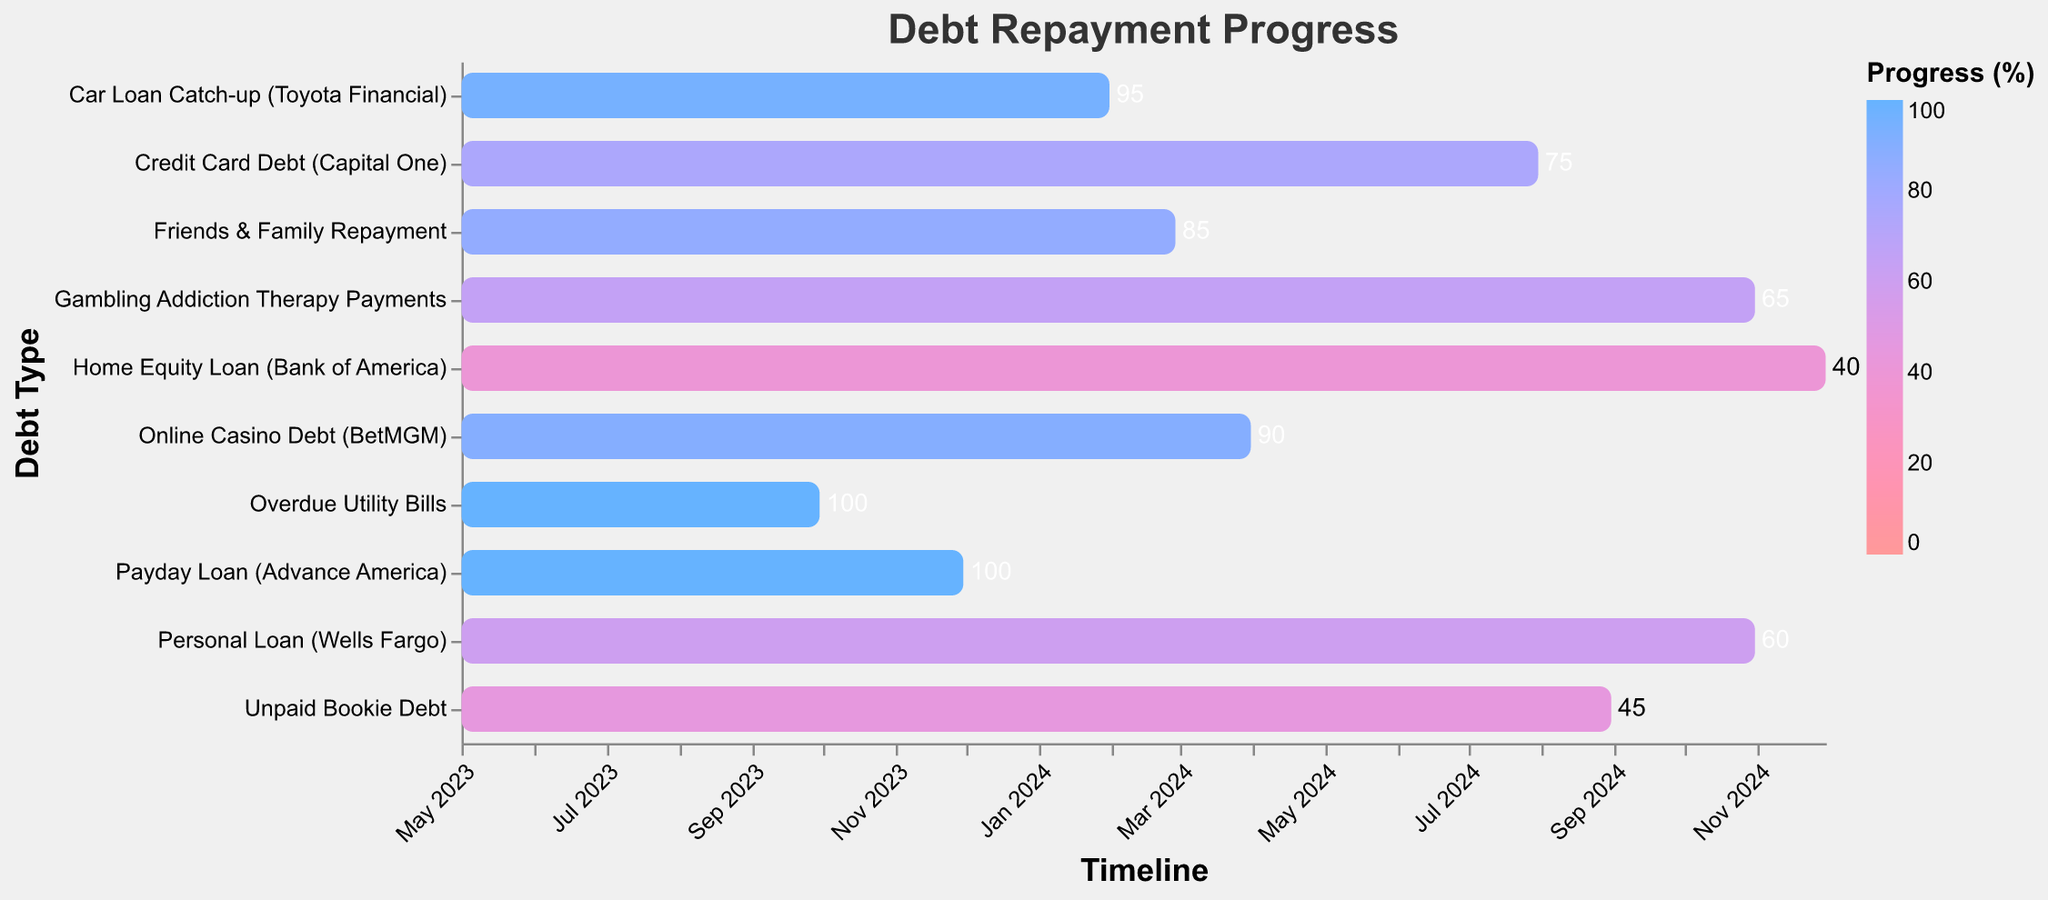Which debt has the highest repayment progress? The debt with the highest repayment progress is the one with the highest percentage on the color scale. By looking at the chart, the "Payday Loan (Advance America)" and "Overdue Utility Bills" both have a progress of 100%.
Answer: Payday Loan (Advance America) and Overdue Utility Bills When is the repayment of the "Online Casino Debt (BetMGM)" expected to be completed? The end date for the "Online Casino Debt (BetMGM)" on the chart indicates when the repayment plan is expected to be completed. The end date is March 31, 2024.
Answer: March 31, 2024 What is the total duration for repaying the "Home Equity Loan (Bank of America)"? To calculate the total duration, subtract the start date from the end date for the "Home Equity Loan (Bank of America)". The start date is May 1, 2023, and the end date is November 30, 2024. The duration is approximately 19 months.
Answer: 19 months Which debts are fully repaid as of now? Fully repaid debts have a progress of 100%. By looking at the chart, "Payday Loan (Advance America)" and "Overdue Utility Bills" have 100% completion.
Answer: Payday Loan (Advance America) and Overdue Utility Bills Which debt has the lowest repayment progress? The debt with the lowest repayment progress is represented by the color with the smallest value on the color scale. "Unpaid Bookie Debt" has the lowest progress at 45%.
Answer: Unpaid Bookie Debt What is the progress of repaying the "Credit Card Debt (Capital One)"? The progress is indicated on the bar for "Credit Card Debt (Capital One)". By looking at the chart, the progress is 75%.
Answer: 75% How many debts have a repayment progress greater than 80%? Count the number of debts with a progress value greater than 80%. By checking the chart, three debts have a repayment progress greater than 80%: "Online Casino Debt (BetMGM)", "Friends & Family Repayment", and "Car Loan Catch-up (Toyota Financial)".
Answer: 3 debts Which debts are expected to be fully repaid by the end of 2023? We need to look at the end dates of debts and see which ones fall within 2023. "Payday Loan (Advance America)" and "Overdue Utility Bills" have end dates in 2023 and are fully repaid.
Answer: Payday Loan (Advance America) and Overdue Utility Bills How does the progress of "Gambling Addiction Therapy Payments" compare to "Personal Loan (Wells Fargo)"? Compare the progress percentages of both debts. "Gambling Addiction Therapy Payments" has a progress of 65%, while "Personal Loan (Wells Fargo)" has a progress of 60%. The former has a higher progress.
Answer: Gambling Addiction Therapy Payments has a higher progress Which debt will be repaid last based on the planned end dates? Look at the end date for each debt and identify the latest date. "Home Equity Loan (Bank of America)" has the latest end date of November 30, 2024.
Answer: Home Equity Loan (Bank of America) 